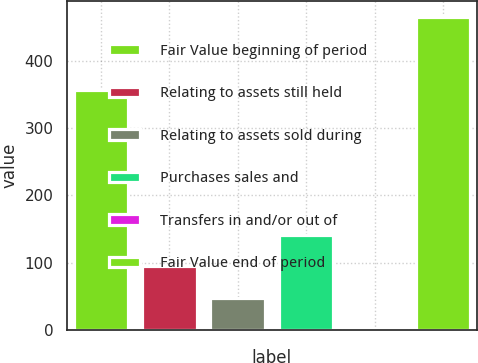Convert chart. <chart><loc_0><loc_0><loc_500><loc_500><bar_chart><fcel>Fair Value beginning of period<fcel>Relating to assets still held<fcel>Relating to assets sold during<fcel>Purchases sales and<fcel>Transfers in and/or out of<fcel>Fair Value end of period<nl><fcel>356<fcel>94.72<fcel>48.44<fcel>141<fcel>2.15<fcel>465<nl></chart> 